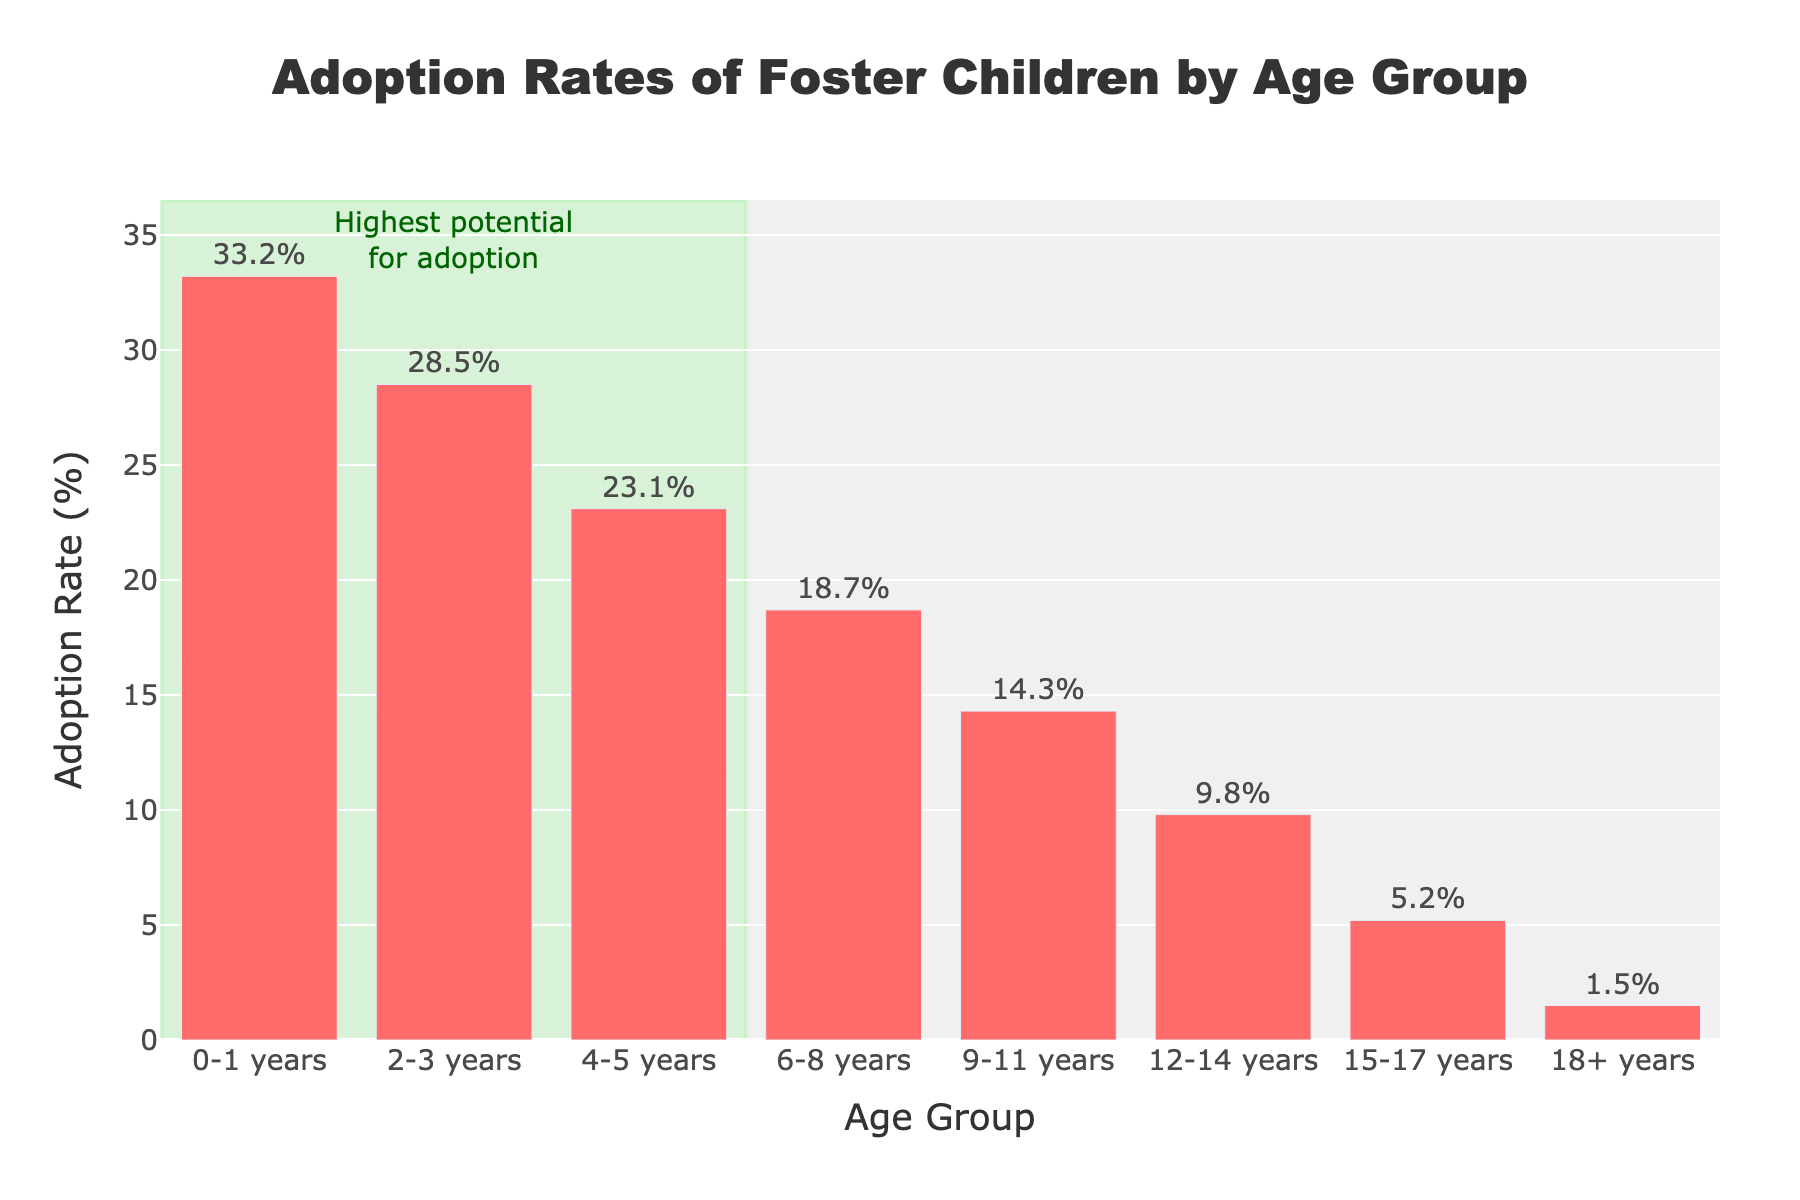What's the adoption rate for the age group 6-8 years? The bar for the age group 6-8 years shows a height corresponding to 18.7%, which is indicated by both the height of the bar and the percentage label directly above it.
Answer: 18.7% Which age group has the highest adoption rate? The figure shows that the bar for the age group 0-1 years is the tallest, corresponding to an adoption rate of 33.2%, indicated by both the height of the bar and the percentage label above it.
Answer: 0-1 years What is the difference in adoption rates between the age groups 2-3 years and 12-14 years? The adoption rate for the 2-3 years age group is 28.5%, and for the 12-14 years age group, it is 9.8%. Subtracting the latter from the former gives 28.5% - 9.8% = 18.7%.
Answer: 18.7% What is the average adoption rate for the age groups below 6 years of age? The age groups below 6 years are 0-1 years, 2-3 years, and 4-5 years, with adoption rates of 33.2%, 28.5%, and 23.1%, respectively. The average is calculated as (33.2 + 28.5 + 23.1) / 3 = 28.27%.
Answer: 28.27% Compare the adoption rates for the age groups 9-11 years and 15-17 years. Which is higher? The adoption rate for the 9-11 years age group is 14.3%, while for the 15-17 years age group, it is 5.2%. Since 14.3% is greater than 5.2%, the adoption rate for 9-11 years is higher.
Answer: 9-11 years Which age group has the lowest adoption rate? The figure shows that the bar for the age group 18+ years is the shortest, corresponding to an adoption rate of 1.5%, indicated by both the height of the bar and the percentage label above it.
Answer: 18+ years What is the cumulative adoption rate for the age groups 6-8, 9-11, and 12-14 years? The adoption rates for 6-8, 9-11, and 12-14 years are 18.7%, 14.3%, and 9.8%, respectively. Summing these gives 18.7% + 14.3% + 9.8% = 42.8%.
Answer: 42.8% Which age group falls in the highlighted area indicating the highest potential for adoption? The highlighted area in the plot starts from 0-1 years and extends up to the 4-5 years age groups. Therefore, the highlighted age groups indicating the highest potential for adoption are 0-1 years, 2-3 years, and 4-5 years.
Answer: 0-5 years How much lower is the adoption rate for the 15-17 years age group compared to the 0-1 years age group? The adoption rate for the 0-1 years age group is 33.2%, and for the 15-17 years age group, it is 5.2%. The difference is 33.2% - 5.2% = 28.0%.
Answer: 28.0% What do the annotations and highlighted areas in the plot signify? The highlighted area in green covers age groups 0-1 years, 2-3 years, and 4-5 years, which is annotated indicating a "Highest potential for adoption". This visually emphasizes that younger children have significantly higher adoption rates.
Answer: Highest potential for adoption of younger children 